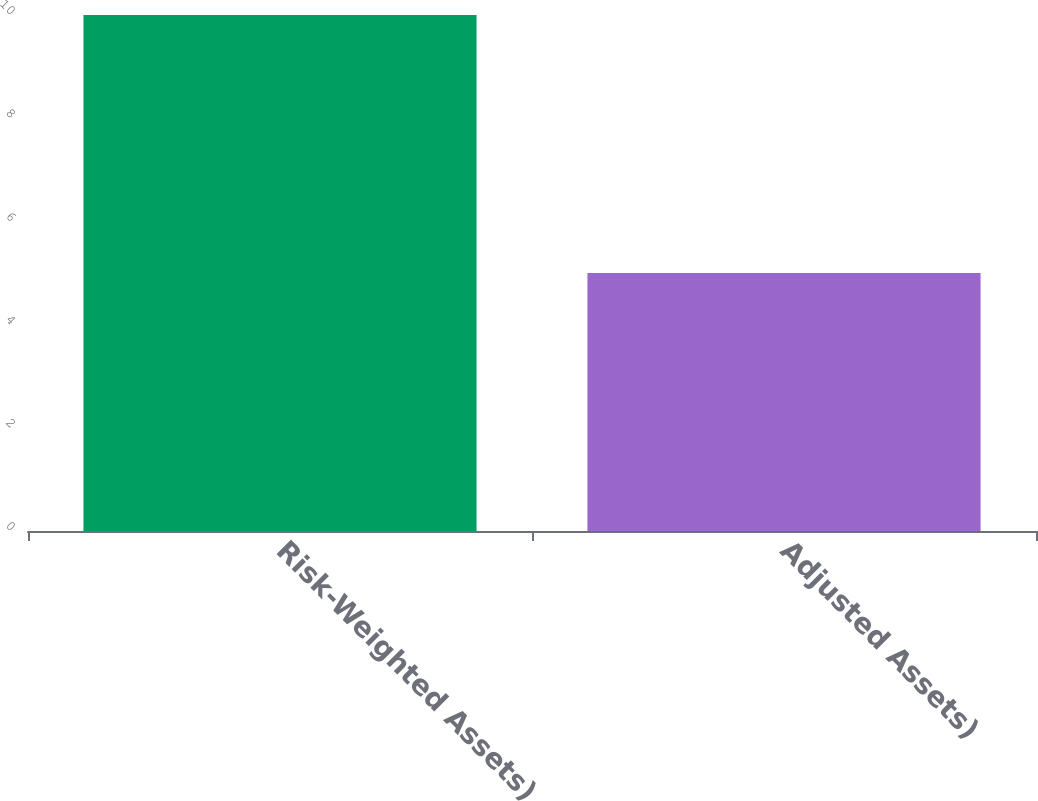<chart> <loc_0><loc_0><loc_500><loc_500><bar_chart><fcel>Risk-Weighted Assets)<fcel>Adjusted Assets)<nl><fcel>10<fcel>5<nl></chart> 